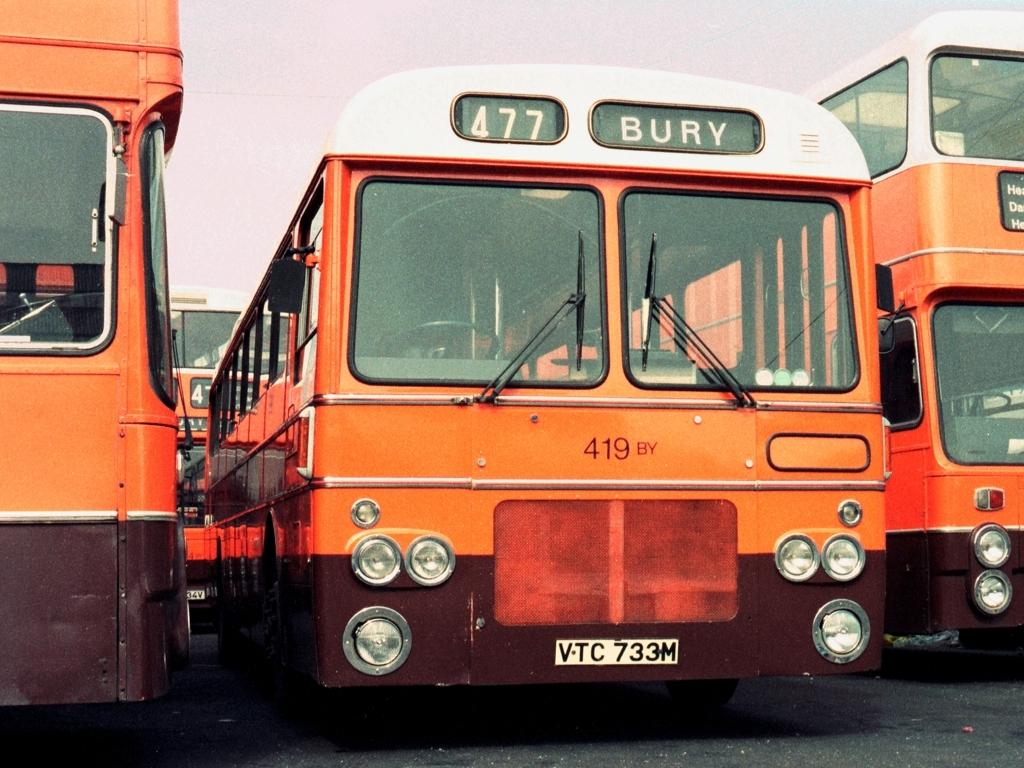Could you estimate the model of the bus? While I cannot provide specific model details, it appears to be a double-decker bus typical of the UK, commonly used for public transportation during the 1970s. 